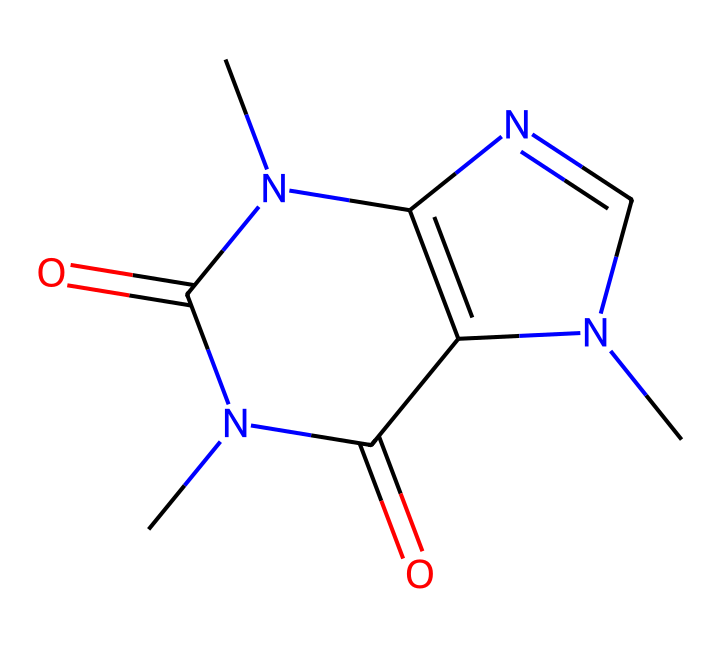What is the chemical name of this compound? The SMILES representation corresponds to caffeine, a well-known alkaloid. The nitrogens and the structural arrangement indicate its classification.
Answer: caffeine How many nitrogen atoms are present in the structure? Analyzing the SMILES, there are three nitrogen atoms indicated in the structure, which can be counted directly.
Answer: three What type of bonding is mainly present in caffeine? The structure contains primarily covalent bonds, as indicated by the connections between atoms. Furthermore, the presence of carbon and nitrogen links suggests covalent character.
Answer: covalent Is this compound classified as a stimulant? Caffeine is recognized for its stimulant properties, which is attributed to its ability to affect the central nervous system, a common trait among many alkaloids.
Answer: yes What is the molecular formula of caffeine derived from the structure? By interpreting the SMILES structure and counting the atoms, the molecular formula for caffeine is derived as C8H10N4O2.
Answer: C8H10N4O2 How does the presence of nitrogen influence the properties of caffeine? Nitrogen atoms contribute to the basicity of caffeine, affecting its solubility and interaction with receptors. This influence imparts the behavioral responses associated with caffeine consumption.
Answer: increases basicity What characteristic of alkaloids does caffeine exhibit? Alkaloids are known for their pharmacological effects, and caffeine specifically shows this through its stimulating effects on the nervous system.
Answer: pharmacological effects 